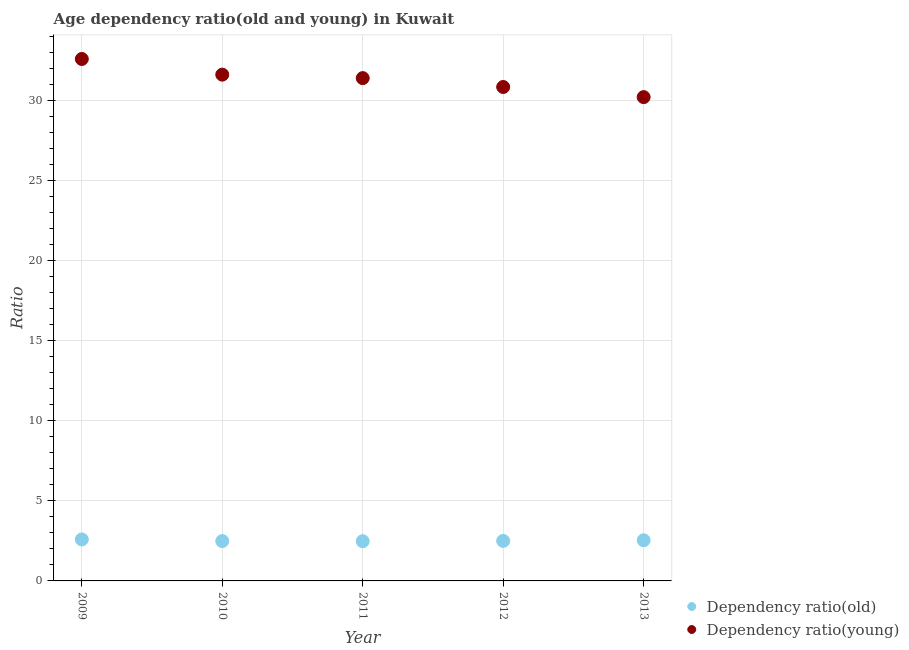How many different coloured dotlines are there?
Give a very brief answer. 2. Is the number of dotlines equal to the number of legend labels?
Offer a terse response. Yes. What is the age dependency ratio(old) in 2010?
Provide a short and direct response. 2.49. Across all years, what is the maximum age dependency ratio(young)?
Your answer should be very brief. 32.59. Across all years, what is the minimum age dependency ratio(old)?
Your response must be concise. 2.48. In which year was the age dependency ratio(young) maximum?
Offer a very short reply. 2009. What is the total age dependency ratio(young) in the graph?
Your response must be concise. 156.66. What is the difference between the age dependency ratio(young) in 2010 and that in 2011?
Provide a succinct answer. 0.22. What is the difference between the age dependency ratio(young) in 2011 and the age dependency ratio(old) in 2010?
Give a very brief answer. 28.91. What is the average age dependency ratio(old) per year?
Make the answer very short. 2.52. In the year 2011, what is the difference between the age dependency ratio(young) and age dependency ratio(old)?
Your response must be concise. 28.92. In how many years, is the age dependency ratio(young) greater than 6?
Keep it short and to the point. 5. What is the ratio of the age dependency ratio(young) in 2010 to that in 2012?
Your response must be concise. 1.02. Is the age dependency ratio(young) in 2009 less than that in 2011?
Provide a short and direct response. No. Is the difference between the age dependency ratio(old) in 2009 and 2013 greater than the difference between the age dependency ratio(young) in 2009 and 2013?
Offer a terse response. No. What is the difference between the highest and the second highest age dependency ratio(old)?
Provide a succinct answer. 0.05. What is the difference between the highest and the lowest age dependency ratio(old)?
Offer a terse response. 0.11. Is the sum of the age dependency ratio(young) in 2010 and 2013 greater than the maximum age dependency ratio(old) across all years?
Make the answer very short. Yes. Is the age dependency ratio(young) strictly less than the age dependency ratio(old) over the years?
Your answer should be very brief. No. How many years are there in the graph?
Make the answer very short. 5. What is the difference between two consecutive major ticks on the Y-axis?
Provide a short and direct response. 5. Does the graph contain grids?
Your response must be concise. Yes. Where does the legend appear in the graph?
Make the answer very short. Bottom right. How many legend labels are there?
Your answer should be very brief. 2. What is the title of the graph?
Provide a short and direct response. Age dependency ratio(old and young) in Kuwait. Does "RDB nonconcessional" appear as one of the legend labels in the graph?
Offer a very short reply. No. What is the label or title of the X-axis?
Your answer should be compact. Year. What is the label or title of the Y-axis?
Your answer should be compact. Ratio. What is the Ratio of Dependency ratio(old) in 2009?
Your answer should be compact. 2.59. What is the Ratio in Dependency ratio(young) in 2009?
Provide a succinct answer. 32.59. What is the Ratio in Dependency ratio(old) in 2010?
Give a very brief answer. 2.49. What is the Ratio in Dependency ratio(young) in 2010?
Your answer should be very brief. 31.61. What is the Ratio of Dependency ratio(old) in 2011?
Your answer should be very brief. 2.48. What is the Ratio in Dependency ratio(young) in 2011?
Offer a terse response. 31.4. What is the Ratio in Dependency ratio(old) in 2012?
Keep it short and to the point. 2.5. What is the Ratio of Dependency ratio(young) in 2012?
Offer a very short reply. 30.84. What is the Ratio of Dependency ratio(old) in 2013?
Offer a very short reply. 2.54. What is the Ratio in Dependency ratio(young) in 2013?
Your response must be concise. 30.21. Across all years, what is the maximum Ratio in Dependency ratio(old)?
Provide a short and direct response. 2.59. Across all years, what is the maximum Ratio of Dependency ratio(young)?
Provide a succinct answer. 32.59. Across all years, what is the minimum Ratio of Dependency ratio(old)?
Ensure brevity in your answer.  2.48. Across all years, what is the minimum Ratio in Dependency ratio(young)?
Make the answer very short. 30.21. What is the total Ratio in Dependency ratio(old) in the graph?
Provide a succinct answer. 12.6. What is the total Ratio in Dependency ratio(young) in the graph?
Your response must be concise. 156.66. What is the difference between the Ratio in Dependency ratio(old) in 2009 and that in 2010?
Offer a terse response. 0.1. What is the difference between the Ratio of Dependency ratio(young) in 2009 and that in 2010?
Make the answer very short. 0.98. What is the difference between the Ratio of Dependency ratio(old) in 2009 and that in 2011?
Provide a short and direct response. 0.11. What is the difference between the Ratio of Dependency ratio(young) in 2009 and that in 2011?
Ensure brevity in your answer.  1.19. What is the difference between the Ratio in Dependency ratio(old) in 2009 and that in 2012?
Offer a terse response. 0.09. What is the difference between the Ratio in Dependency ratio(young) in 2009 and that in 2012?
Your answer should be very brief. 1.75. What is the difference between the Ratio of Dependency ratio(old) in 2009 and that in 2013?
Your response must be concise. 0.05. What is the difference between the Ratio in Dependency ratio(young) in 2009 and that in 2013?
Provide a succinct answer. 2.38. What is the difference between the Ratio of Dependency ratio(old) in 2010 and that in 2011?
Offer a terse response. 0.01. What is the difference between the Ratio of Dependency ratio(young) in 2010 and that in 2011?
Ensure brevity in your answer.  0.22. What is the difference between the Ratio in Dependency ratio(old) in 2010 and that in 2012?
Your response must be concise. -0.01. What is the difference between the Ratio of Dependency ratio(young) in 2010 and that in 2012?
Provide a short and direct response. 0.77. What is the difference between the Ratio in Dependency ratio(young) in 2010 and that in 2013?
Your answer should be very brief. 1.4. What is the difference between the Ratio in Dependency ratio(old) in 2011 and that in 2012?
Your answer should be compact. -0.02. What is the difference between the Ratio in Dependency ratio(young) in 2011 and that in 2012?
Give a very brief answer. 0.55. What is the difference between the Ratio in Dependency ratio(old) in 2011 and that in 2013?
Make the answer very short. -0.06. What is the difference between the Ratio of Dependency ratio(young) in 2011 and that in 2013?
Your answer should be compact. 1.19. What is the difference between the Ratio in Dependency ratio(old) in 2012 and that in 2013?
Ensure brevity in your answer.  -0.04. What is the difference between the Ratio in Dependency ratio(young) in 2012 and that in 2013?
Provide a succinct answer. 0.63. What is the difference between the Ratio of Dependency ratio(old) in 2009 and the Ratio of Dependency ratio(young) in 2010?
Offer a terse response. -29.02. What is the difference between the Ratio of Dependency ratio(old) in 2009 and the Ratio of Dependency ratio(young) in 2011?
Offer a very short reply. -28.81. What is the difference between the Ratio in Dependency ratio(old) in 2009 and the Ratio in Dependency ratio(young) in 2012?
Ensure brevity in your answer.  -28.25. What is the difference between the Ratio in Dependency ratio(old) in 2009 and the Ratio in Dependency ratio(young) in 2013?
Your answer should be very brief. -27.62. What is the difference between the Ratio in Dependency ratio(old) in 2010 and the Ratio in Dependency ratio(young) in 2011?
Ensure brevity in your answer.  -28.91. What is the difference between the Ratio in Dependency ratio(old) in 2010 and the Ratio in Dependency ratio(young) in 2012?
Offer a very short reply. -28.36. What is the difference between the Ratio in Dependency ratio(old) in 2010 and the Ratio in Dependency ratio(young) in 2013?
Give a very brief answer. -27.72. What is the difference between the Ratio of Dependency ratio(old) in 2011 and the Ratio of Dependency ratio(young) in 2012?
Your answer should be compact. -28.37. What is the difference between the Ratio of Dependency ratio(old) in 2011 and the Ratio of Dependency ratio(young) in 2013?
Your response must be concise. -27.73. What is the difference between the Ratio of Dependency ratio(old) in 2012 and the Ratio of Dependency ratio(young) in 2013?
Provide a short and direct response. -27.71. What is the average Ratio in Dependency ratio(old) per year?
Your response must be concise. 2.52. What is the average Ratio in Dependency ratio(young) per year?
Offer a very short reply. 31.33. In the year 2009, what is the difference between the Ratio of Dependency ratio(old) and Ratio of Dependency ratio(young)?
Your answer should be very brief. -30. In the year 2010, what is the difference between the Ratio in Dependency ratio(old) and Ratio in Dependency ratio(young)?
Keep it short and to the point. -29.13. In the year 2011, what is the difference between the Ratio of Dependency ratio(old) and Ratio of Dependency ratio(young)?
Your answer should be compact. -28.92. In the year 2012, what is the difference between the Ratio of Dependency ratio(old) and Ratio of Dependency ratio(young)?
Offer a terse response. -28.34. In the year 2013, what is the difference between the Ratio of Dependency ratio(old) and Ratio of Dependency ratio(young)?
Your answer should be very brief. -27.67. What is the ratio of the Ratio in Dependency ratio(old) in 2009 to that in 2010?
Offer a terse response. 1.04. What is the ratio of the Ratio of Dependency ratio(young) in 2009 to that in 2010?
Provide a short and direct response. 1.03. What is the ratio of the Ratio in Dependency ratio(old) in 2009 to that in 2011?
Provide a short and direct response. 1.04. What is the ratio of the Ratio of Dependency ratio(young) in 2009 to that in 2011?
Your response must be concise. 1.04. What is the ratio of the Ratio in Dependency ratio(old) in 2009 to that in 2012?
Your answer should be very brief. 1.04. What is the ratio of the Ratio of Dependency ratio(young) in 2009 to that in 2012?
Give a very brief answer. 1.06. What is the ratio of the Ratio in Dependency ratio(old) in 2009 to that in 2013?
Your response must be concise. 1.02. What is the ratio of the Ratio of Dependency ratio(young) in 2009 to that in 2013?
Ensure brevity in your answer.  1.08. What is the ratio of the Ratio in Dependency ratio(old) in 2010 to that in 2011?
Make the answer very short. 1. What is the ratio of the Ratio in Dependency ratio(young) in 2010 to that in 2012?
Keep it short and to the point. 1.02. What is the ratio of the Ratio of Dependency ratio(old) in 2010 to that in 2013?
Offer a very short reply. 0.98. What is the ratio of the Ratio of Dependency ratio(young) in 2010 to that in 2013?
Your answer should be very brief. 1.05. What is the ratio of the Ratio in Dependency ratio(old) in 2011 to that in 2012?
Offer a terse response. 0.99. What is the ratio of the Ratio in Dependency ratio(young) in 2011 to that in 2012?
Make the answer very short. 1.02. What is the ratio of the Ratio in Dependency ratio(old) in 2011 to that in 2013?
Make the answer very short. 0.98. What is the ratio of the Ratio in Dependency ratio(young) in 2011 to that in 2013?
Ensure brevity in your answer.  1.04. What is the ratio of the Ratio of Dependency ratio(old) in 2012 to that in 2013?
Offer a very short reply. 0.98. What is the ratio of the Ratio of Dependency ratio(young) in 2012 to that in 2013?
Your response must be concise. 1.02. What is the difference between the highest and the second highest Ratio of Dependency ratio(old)?
Provide a succinct answer. 0.05. What is the difference between the highest and the second highest Ratio of Dependency ratio(young)?
Your answer should be compact. 0.98. What is the difference between the highest and the lowest Ratio in Dependency ratio(old)?
Keep it short and to the point. 0.11. What is the difference between the highest and the lowest Ratio of Dependency ratio(young)?
Offer a very short reply. 2.38. 